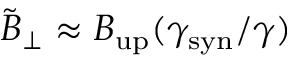Convert formula to latex. <formula><loc_0><loc_0><loc_500><loc_500>\tilde { B } _ { \perp } \approx B _ { u p } ( \gamma _ { s y n } / \gamma )</formula> 